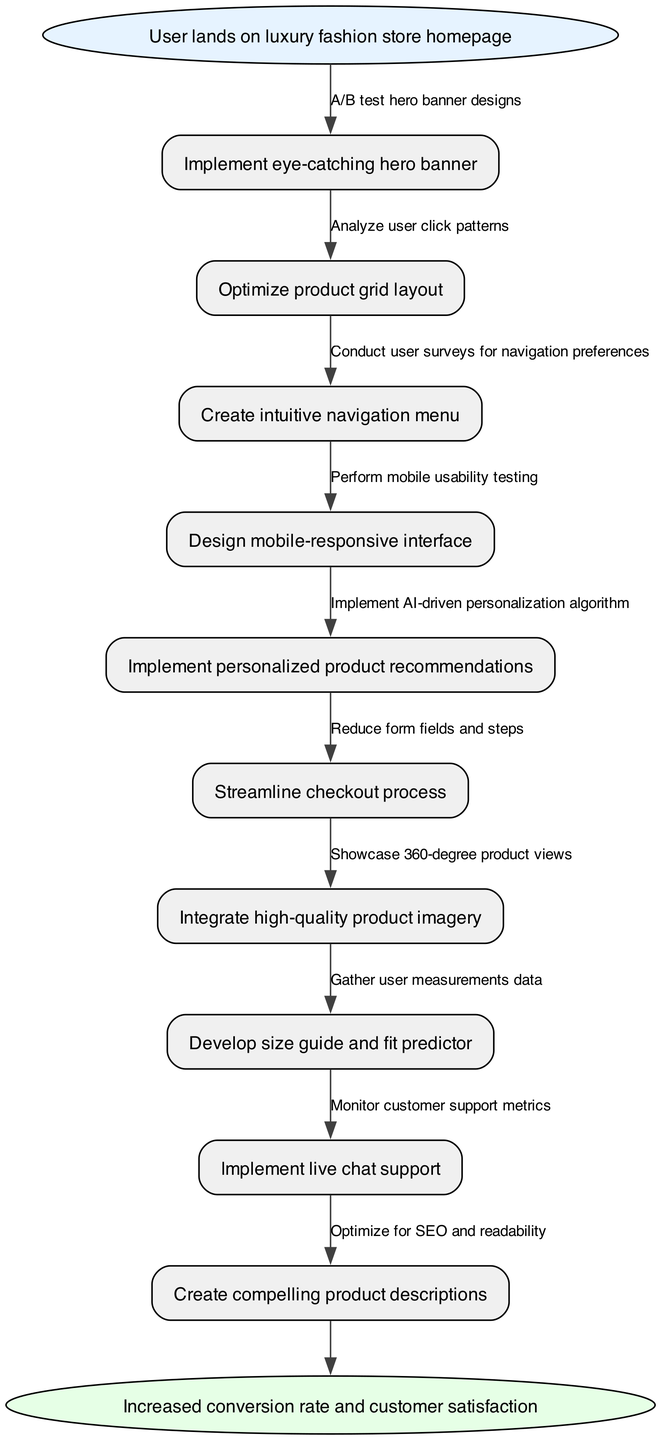What is the starting point of the pathway? The diagram begins with the node labeled "User lands on luxury fashion store homepage." This is explicitly marked as the start node, indicating the initial action in the pathway.
Answer: User lands on luxury fashion store homepage How many nodes are in the diagram? There are ten nodes in total, including the start and end nodes. Counting each of the intermediate actions, we arrive at this total.
Answer: 10 What is the last action before reaching the end node? The final action before arriving at the end node is "Create compelling product descriptions." This can be identified as the last node in the sequence, leading directly to the endpoint.
Answer: Create compelling product descriptions Which optimization technique follows the "Implement eye-catching hero banner"? The action that directly follows "Implement eye-catching hero banner" is "Optimize product grid layout." The connecting edge outlines this sequence.
Answer: Optimize product grid layout What is the focus of the end node? The end node focuses on "Increased conversion rate and customer satisfaction." It provides the ultimate goal of the pathway.
Answer: Increased conversion rate and customer satisfaction What action involves real-time customer interaction? The action that involves real-time customer interaction is "Implement live chat support." This can be deduced from its function of facilitating direct communication with customers.
Answer: Implement live chat support Which node is connected to the "Streamline checkout process"? The node connected to "Streamline checkout process" is "Integrate high-quality product imagery." The edge connecting these two indicates the flow of actions in the diagram.
Answer: Integrate high-quality product imagery What is the significance of conducting user surveys? Conducting user surveys is significant for gathering "navigation preferences." This step is crucial for optimizing the user's journey on the website.
Answer: navigation preferences Which two nodes focus on product presentation? The two nodes that focus on product presentation are "Integrate high-quality product imagery" and "Showcase 360-degree product views." Both emphasize enhancing how products are displayed to users.
Answer: Integrate high-quality product imagery, Showcase 360-degree product views 